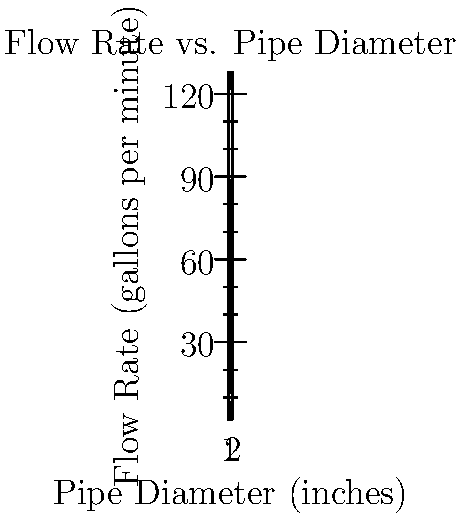As a family business owner looking to expand your operations, you're considering upgrading your water supply system. Based on the graph showing the relationship between pipe diameter and flow rate, what would be the approximate flow rate increase if you were to replace a 1-inch diameter pipe with a 2-inch diameter pipe in your main water line? To solve this problem, we'll follow these steps:

1. Identify the flow rates for 1-inch and 2-inch pipes from the graph:
   - For 1-inch pipe: approximately 16 gallons per minute (gpm)
   - For 2-inch pipe: approximately 128 gpm

2. Calculate the difference in flow rates:
   $\text{Increase} = \text{Flow rate (2-inch)} - \text{Flow rate (1-inch)}$
   $\text{Increase} = 128 \text{ gpm} - 16 \text{ gpm} = 112 \text{ gpm}$

3. To express this as a percentage increase:
   $\text{Percentage increase} = \frac{\text{Increase}}{\text{Original flow rate}} \times 100\%$
   $\text{Percentage increase} = \frac{112 \text{ gpm}}{16 \text{ gpm}} \times 100\% = 700\%$

Therefore, replacing a 1-inch diameter pipe with a 2-inch diameter pipe would increase the flow rate by approximately 112 gpm, or 700%.
Answer: 112 gpm (700% increase) 